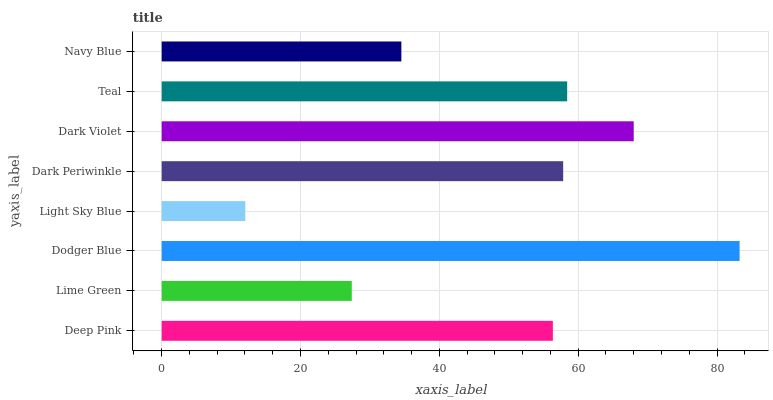Is Light Sky Blue the minimum?
Answer yes or no. Yes. Is Dodger Blue the maximum?
Answer yes or no. Yes. Is Lime Green the minimum?
Answer yes or no. No. Is Lime Green the maximum?
Answer yes or no. No. Is Deep Pink greater than Lime Green?
Answer yes or no. Yes. Is Lime Green less than Deep Pink?
Answer yes or no. Yes. Is Lime Green greater than Deep Pink?
Answer yes or no. No. Is Deep Pink less than Lime Green?
Answer yes or no. No. Is Dark Periwinkle the high median?
Answer yes or no. Yes. Is Deep Pink the low median?
Answer yes or no. Yes. Is Teal the high median?
Answer yes or no. No. Is Navy Blue the low median?
Answer yes or no. No. 